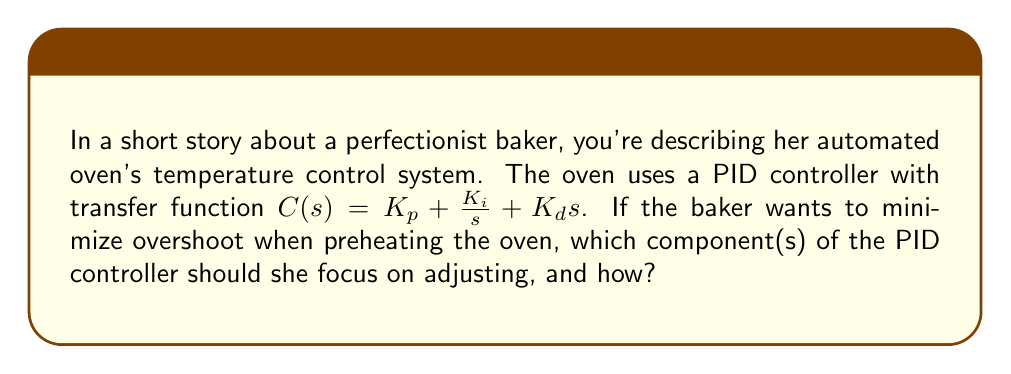Could you help me with this problem? To answer this question, we need to understand the role of each component in a PID (Proportional-Integral-Derivative) controller and their effects on system response, particularly overshoot.

1. Proportional (P) term: $K_p$
   - Reduces rise time
   - Increases overshoot
   - Decreases steady-state error

2. Integral (I) term: $K_i$
   - Eliminates steady-state error
   - Increases overshoot
   - Increases settling time

3. Derivative (D) term: $K_d$
   - Reduces overshoot
   - Improves stability
   - May amplify noise in the system

To minimize overshoot, we should focus on:

1. Increasing the derivative gain $K_d$:
   The derivative term acts on the rate of change of the error. It provides a dampening effect, which helps reduce overshoot by anticipating and counteracting rapid changes in the error.

2. Decreasing the integral gain $K_i$:
   While the integral term is crucial for eliminating steady-state error, it can contribute to overshoot. Reducing $K_i$ can help minimize overshoot, but care should be taken not to eliminate it entirely, as it's needed for zero steady-state error.

3. Fine-tuning the proportional gain $K_p$:
   The proportional term can be adjusted to balance the system's response. Decreasing $K_p$ can help reduce overshoot, but it may also slow down the system's response.

The baker should focus on increasing $K_d$ and decreasing $K_i$, while carefully adjusting $K_p$ to maintain a good balance between response time and overshoot reduction.
Answer: The baker should focus on increasing the derivative gain $K_d$ and decreasing the integral gain $K_i$ to minimize overshoot in the oven's temperature control system. Fine-tuning the proportional gain $K_p$ may also be necessary to achieve the optimal balance between response time and overshoot reduction. 